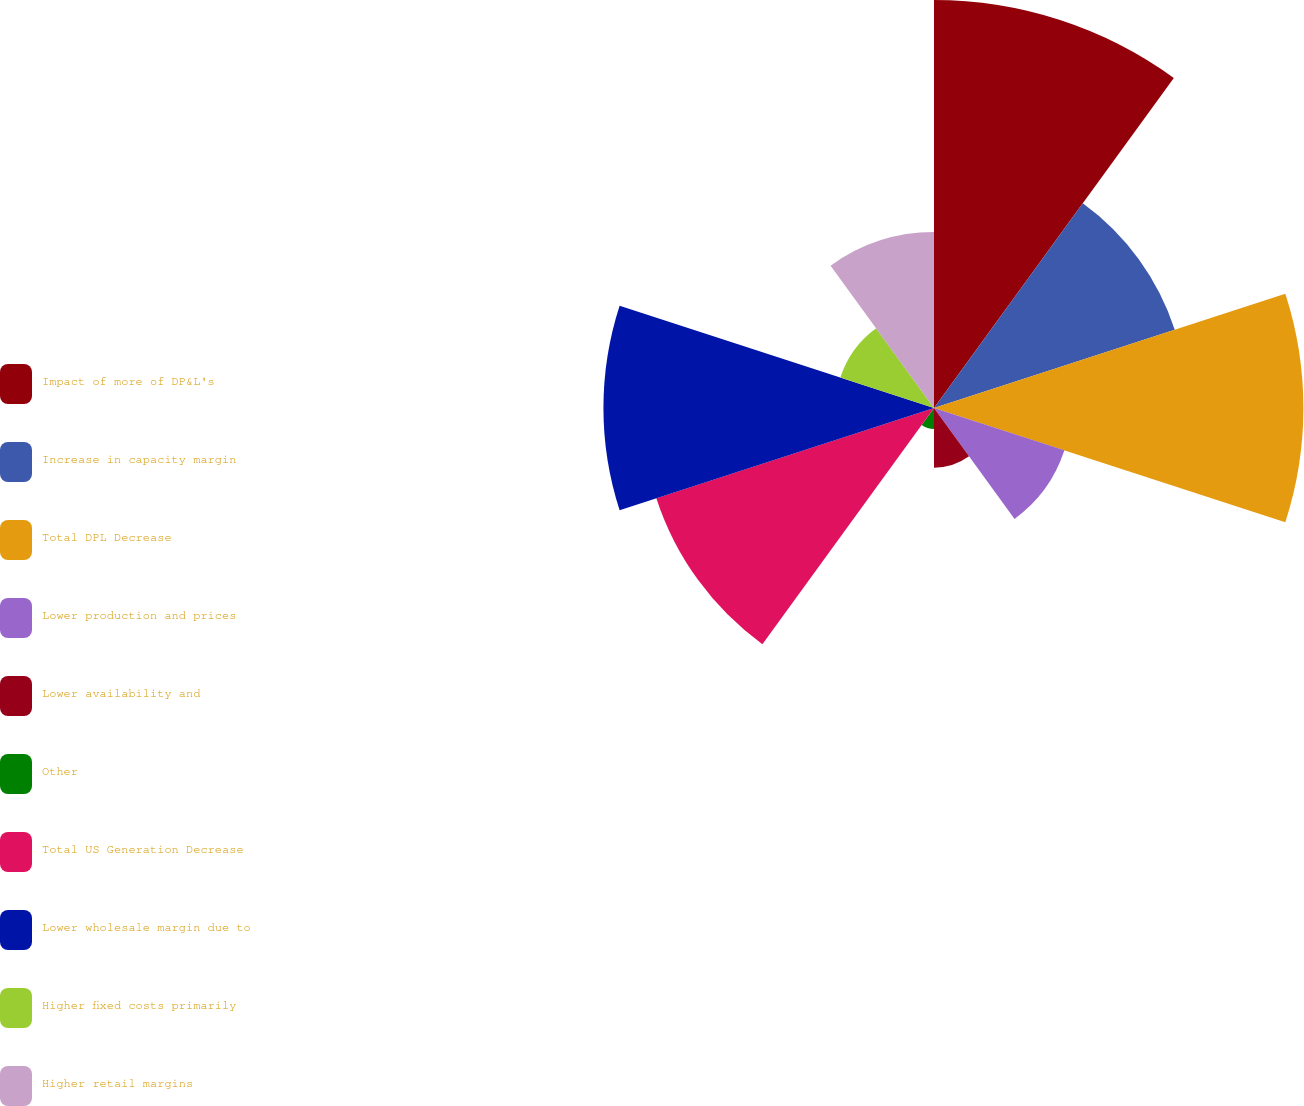<chart> <loc_0><loc_0><loc_500><loc_500><pie_chart><fcel>Impact of more of DP&L's<fcel>Increase in capacity margin<fcel>Total DPL Decrease<fcel>Lower production and prices<fcel>Lower availability and<fcel>Other<fcel>Total US Generation Decrease<fcel>Lower wholesale margin due to<fcel>Higher fixed costs primarily<fcel>Higher retail margins<nl><fcel>19.02%<fcel>11.8%<fcel>17.22%<fcel>6.39%<fcel>2.78%<fcel>0.98%<fcel>13.61%<fcel>15.41%<fcel>4.59%<fcel>8.2%<nl></chart> 